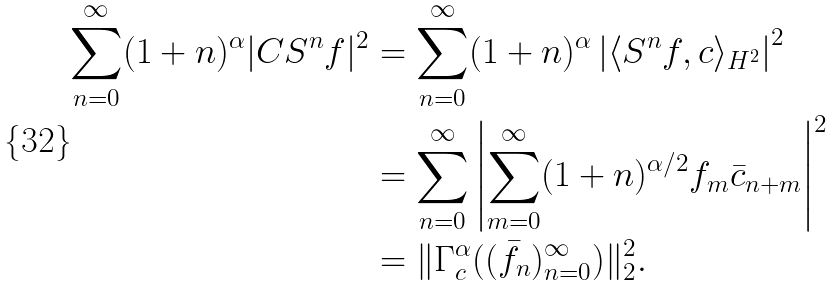Convert formula to latex. <formula><loc_0><loc_0><loc_500><loc_500>\sum _ { n = 0 } ^ { \infty } ( 1 + n ) ^ { \alpha } | C S ^ { n } f | ^ { 2 } & = \sum _ { n = 0 } ^ { \infty } ( 1 + n ) ^ { \alpha } \left | \langle S ^ { n } f , c \rangle _ { H ^ { 2 } } \right | ^ { 2 } \\ & = \sum _ { n = 0 } ^ { \infty } \left | \sum _ { m = 0 } ^ { \infty } ( 1 + n ) ^ { \alpha / 2 } f _ { m } \bar { c } _ { n + m } \right | ^ { 2 } \\ & = \| \Gamma _ { c } ^ { \alpha } ( ( \bar { f } _ { n } ) _ { n = 0 } ^ { \infty } ) \| _ { 2 } ^ { 2 } .</formula> 